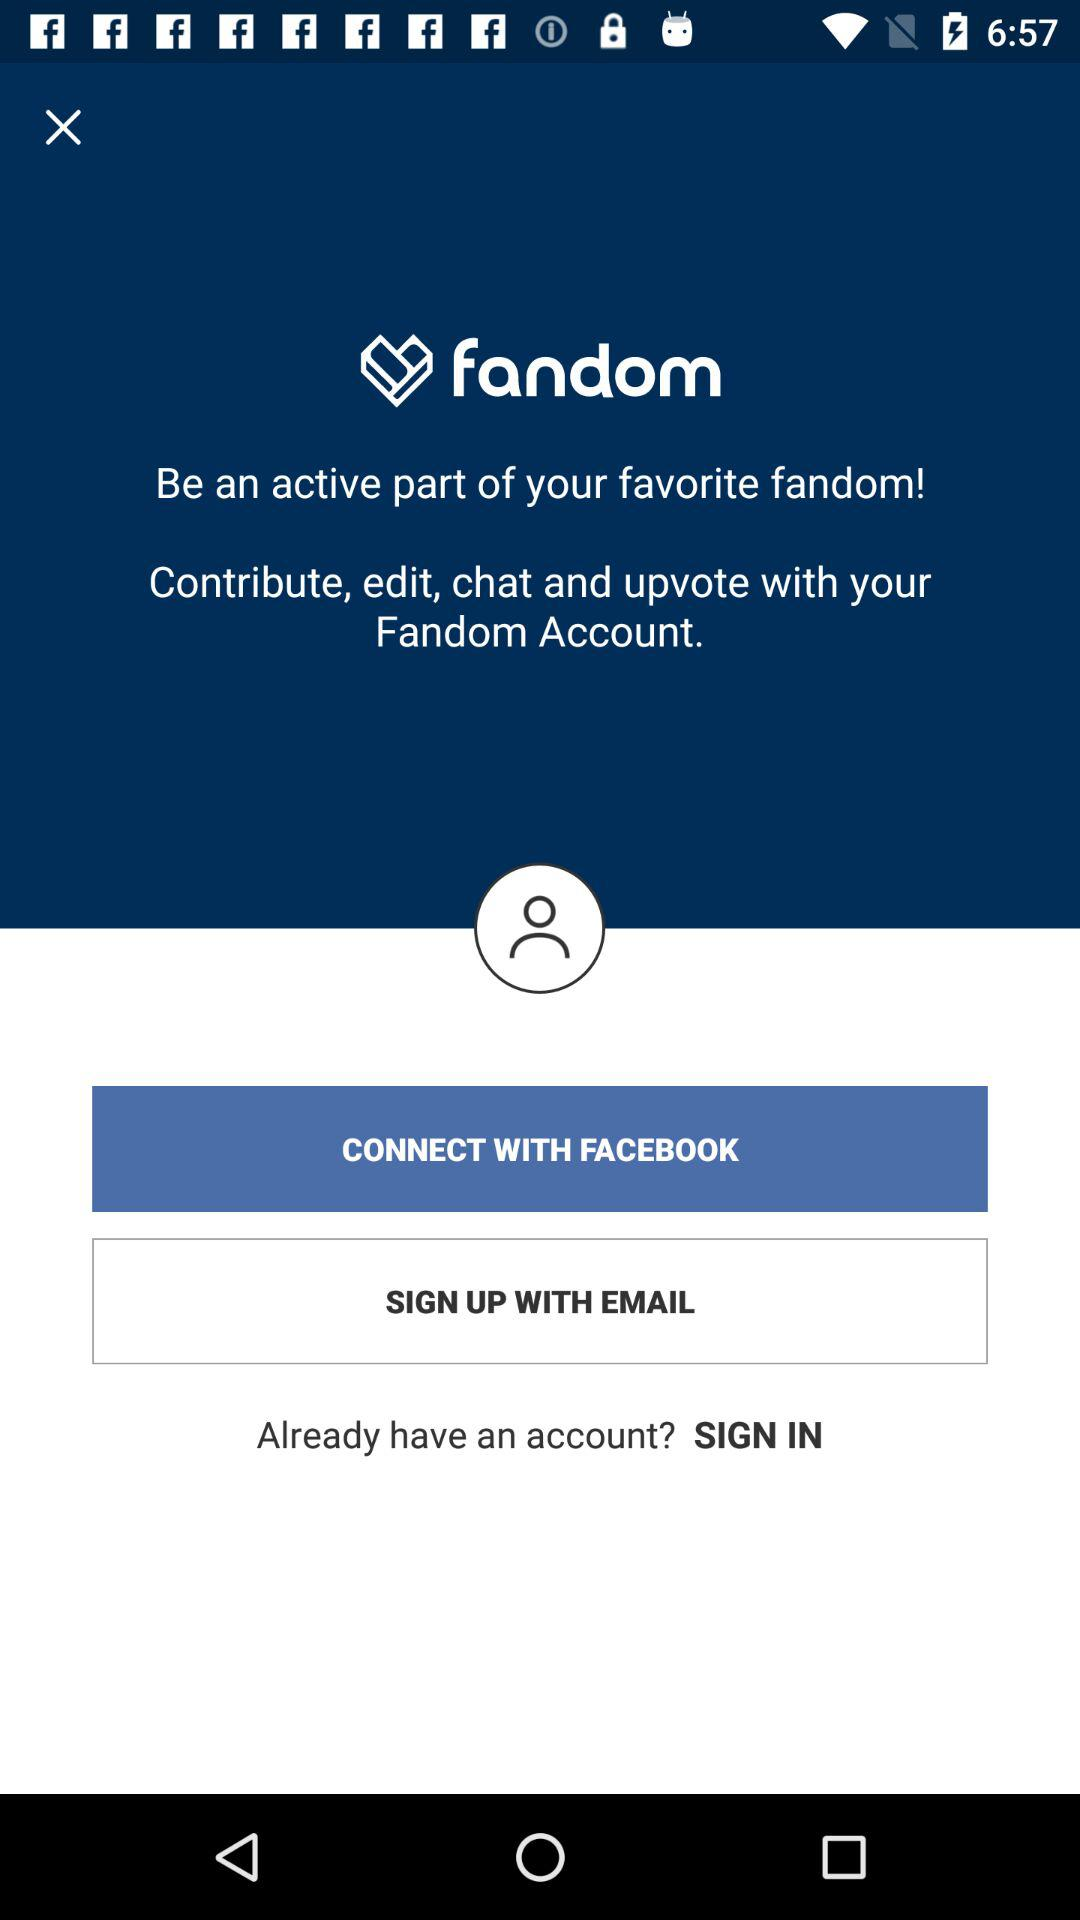What is the application name? The application name is "fandom". 